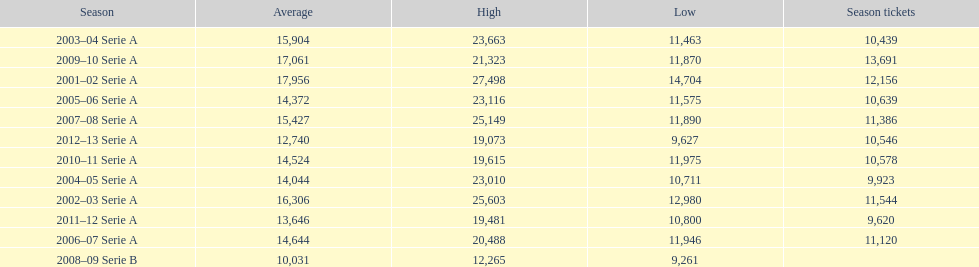How many seasons had average attendance of at least 15,000 at the stadio ennio tardini? 5. 